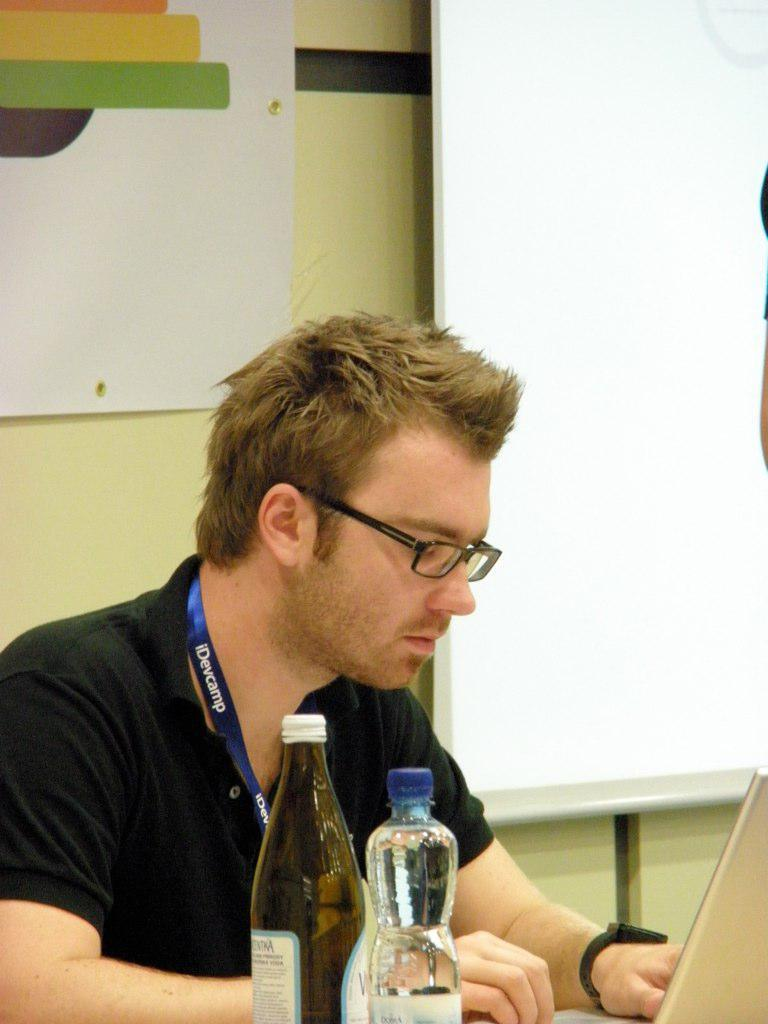What is the man in the image doing? The man is sitting and using a laptop in the image. How many laptops are visible in front of the man? There are two laptops in front of the man. What can be seen in the background of the image? There is a board and a wall in the background of the image. What type of pets can be seen playing with the man in the image? There are no pets visible in the image; the man is using a laptop and there are no animals present. 